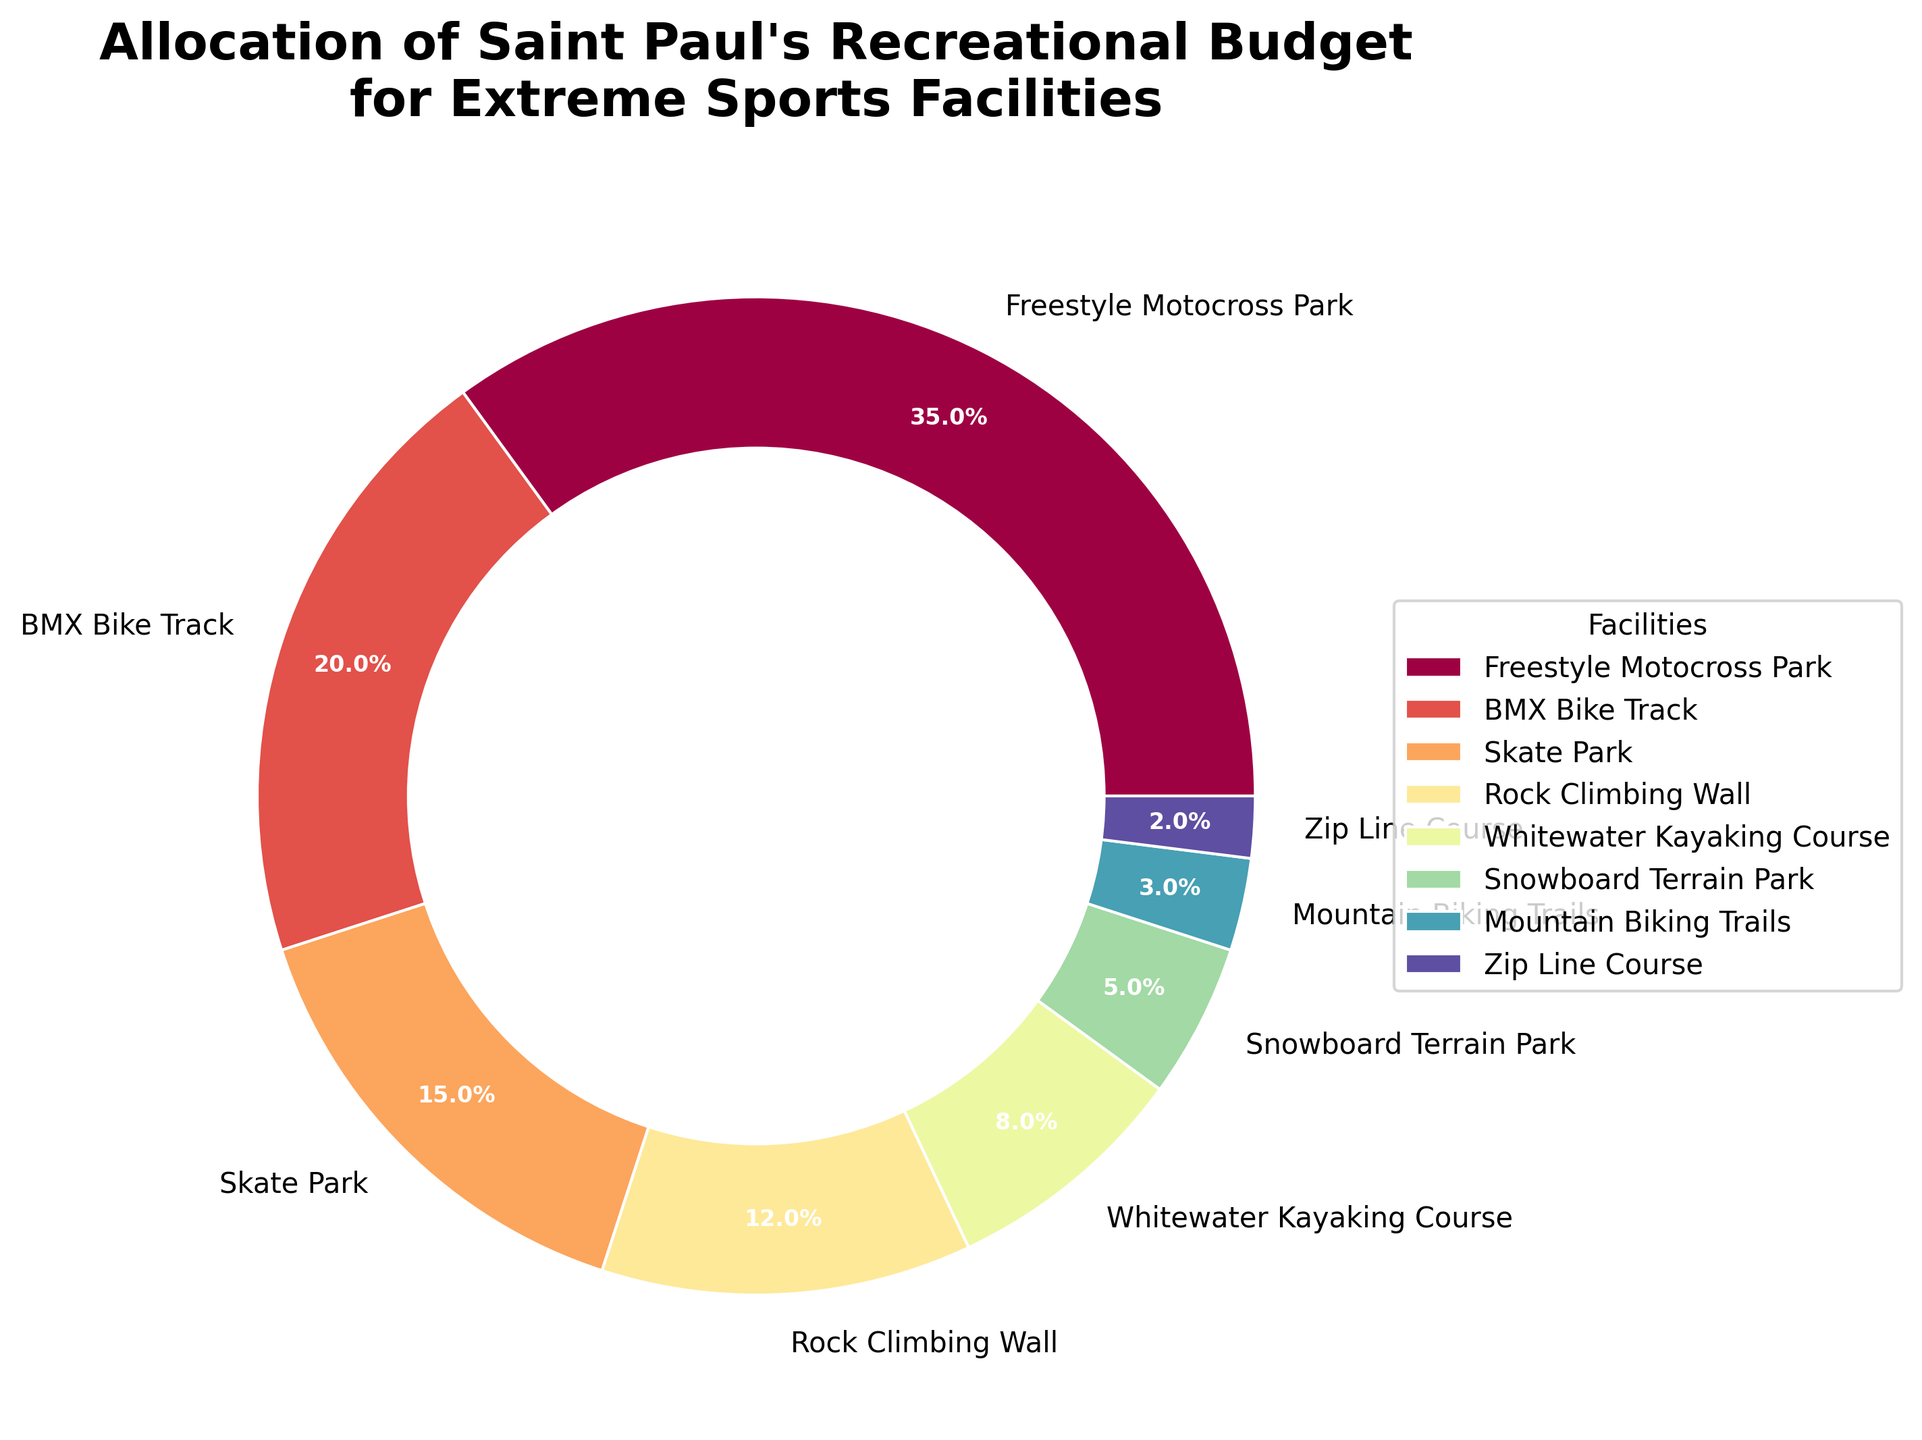What percentage of the budget is allocated to Freestyle Motocross Park? The slice of the pie chart that represents the Freestyle Motocross Park shows a percentage label.
Answer: 35% How much higher is the budget allocation for BMX Bike Track compared to the Skate Park? The pie chart shows that BMX Bike Track has a budget allocation of 20% whereas the Skate Park has 15%. The difference is calculated as 20% - 15%.
Answer: 5% Which facility has the smallest allocation in the budget? Identify the slice with the smallest percentage label in the pie chart.
Answer: Zip Line Course If we combine the budgets for the Snowboard Terrain Park, Mountain Biking Trails, and Zip Line Course, what percentage of the total budget do they represent? Add the percentages shown for Snowboard Terrain Park (5%), Mountain Biking Trails (3%), and Zip Line Course (2%) together.
Answer: 10% What is the combined allocation for Rock Climbing Wall and Whitewater Kayaking Course? Add the percentages shown for Rock Climbing Wall (12%) and Whitewater Kayaking Course (8%) together.
Answer: 20% Is the budget allocation for Freestyle Motocross Park greater than the combined budget for Rock Climbing Wall and Whitewater Kayaking Course? Compare the percentage for Freestyle Motocross Park (35%) to the combined percentage for Rock Climbing Wall and Whitewater Kayaking Course (12% + 8% = 20%).
Answer: Yes Which facility has twice the budget allocation percentage of the Skate Park? Skate Park has a 15% allocation. Look for a facility with 30% allocation. None exist with exactly 30%, so the answer is none.
Answer: None Which facility on the chart is allocated with a green color wedge? Examine the pie chart for the wedge corresponding to the green color. The specific facility associated with it can be identified.
Answer: This question relies on the actual colors visible on the pie chart, which we don't have a description of here What is the average budget allocation for the Skate Park, Freestyle Motocross Park, and BMX Bike Track? Add the percentages for Skate Park (15%), Freestyle Motocross Park (35%), and BMX Bike Track (20%) and then divide by 3. (15% + 35% + 20%) / 3 = 70% / 3
Answer: 23.3% Is the budget allocation for the Mountain Biking Trails less than half of the budget for the Rock Climbing Wall? Mountain Biking Trails has a 3% allocation, while Rock Climbing Wall has 12%. Check if 3% is less than half of 12%. 12% / 2 = 6%, and 3% < 6%.
Answer: Yes 